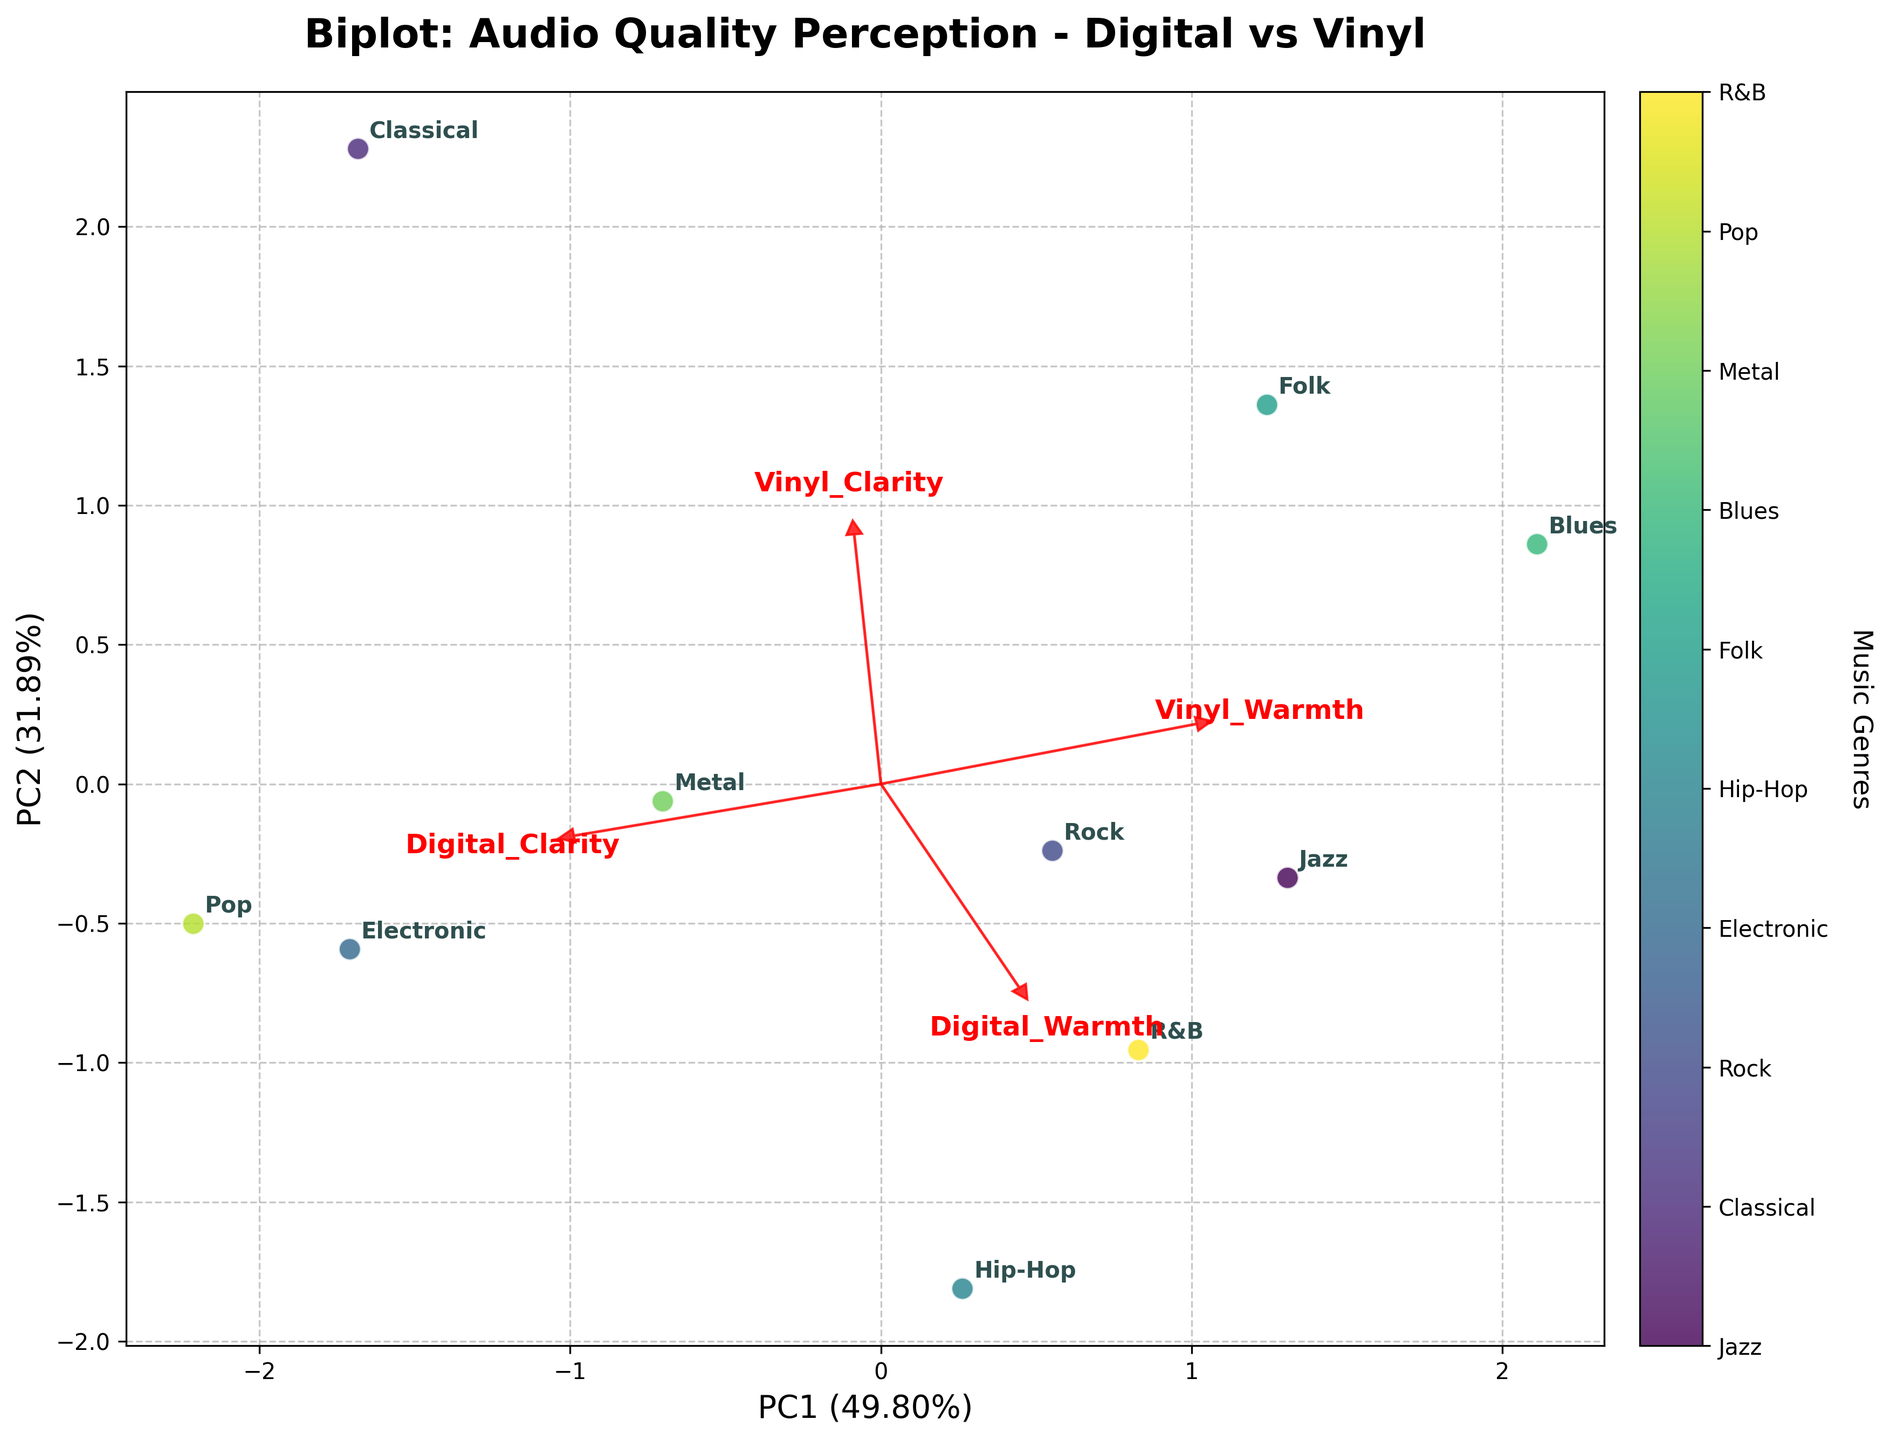1. What's the title of the Biplot? The title is located at the top of the chart and usually summarizes the main focus or topic of the plot. In this case, it reads "Biplot: Audio Quality Perception - Digital vs Vinyl."
Answer: Biplot: Audio Quality Perception - Digital vs Vinyl 2. How many music genres are compared in this Biplot? You can count the number of labeled points on the plot corresponding to different music genres. Each distinct label represents a genre.
Answer: 10 3. Which music genre is closest to the first principal component (PC1) axis? Find the genre label that is positioned most closely to the horizontal axis among all points.
Answer: Electronic 4. Which vector indicates 'Vinyl Warmth' in the Biplot? Look for the red vectors and find the one labeled as 'Vinyl Warmth.' The arrows represent the loading vectors of each feature.
Answer: The arrow pointing towards the upper right, labeled 'Vinyl Warmth.' 5. Which genre appears to have the highest perception of 'Digital Clarity' based on the Biplot? Identify the position of genres relative to the 'Digital Clarity' loading vector. The genre closest to the direction of this vector likely has the highest perception.
Answer: Electronic 6. Identify the genres that are positioned nearer to the 'Vinyl Warmth' loading vector than the 'Digital Clarity' loading vector. Look for genres close to the 'Vinyl Warmth' vector; these are typically positioned in the direction away from the 'Digital Clarity.'
Answer: Jazz, Folk, Blues 7. What does the first principal component (PC1) represent more of, 'Digital' or 'Vinyl' characteristics? Examine the loading vectors relative to the PC1 axis. If more vectors labeled 'Digital' are aligned along PC1, it represents 'Digital' characteristics.
Answer: Digital 8. Compare the perception of 'Vinyl Clarity' and 'Vinyl Warmth' for the genre closest to the 'Vinyl Warmth' vector. Identify the genre near the 'Vinyl Warmth' vector and check its position relative to the 'Vinyl Clarity' vector.
Answer: Blues; closer to 'Vinyl Warmth' than 'Vinyl Clarity.' 9. Which principal component (PC1 or PC2) explains more variance in the data? Look at the percentage values in parentheses next to the PC1 and PC2 labels on the axes. The one with a higher value explains more variance.
Answer: PC1 10. Do Rock and Metal genres appear closer to each other or farther apart in the Biplot? Locate the points labeled 'Rock' and 'Metal' and see if they are plotted near each other or far apart.
Answer: Closer 